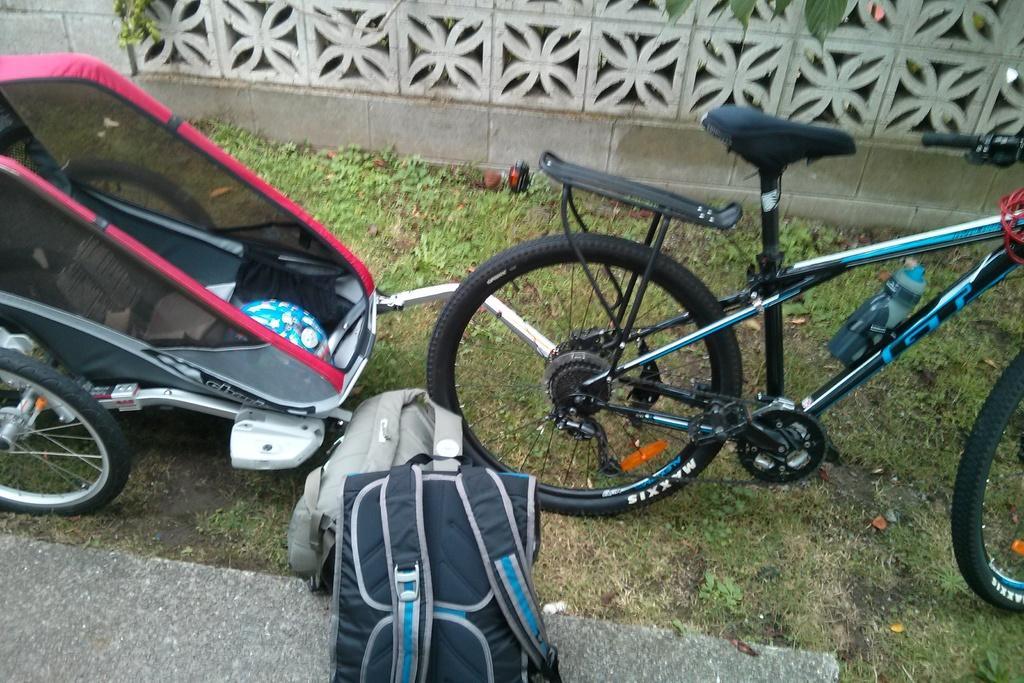Please provide a concise description of this image. In this picture I can see a bicycle and a stroller and I can see couple of backpacks on the floor and I can see a wall and grass on the ground. 